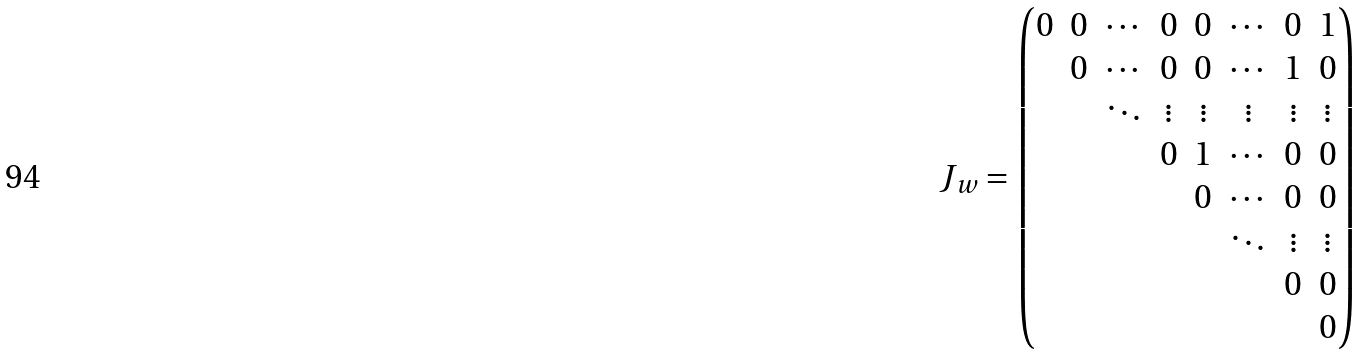Convert formula to latex. <formula><loc_0><loc_0><loc_500><loc_500>J _ { w } = \begin{pmatrix} 0 & 0 & \cdots & 0 & 0 & \cdots & 0 & 1 \\ & 0 & \cdots & 0 & 0 & \cdots & 1 & 0 \\ & & \ddots & \vdots & \vdots & \vdots & \vdots & \vdots \\ & & & 0 & 1 & \cdots & 0 & 0 \\ & & & & 0 & \cdots & 0 & 0 \\ & & & & & \ddots & \vdots & \vdots \\ & & & & & & 0 & 0 \\ & & & & & & & 0 \\ \end{pmatrix}</formula> 